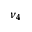<formula> <loc_0><loc_0><loc_500><loc_500>\nu _ { 4 }</formula> 